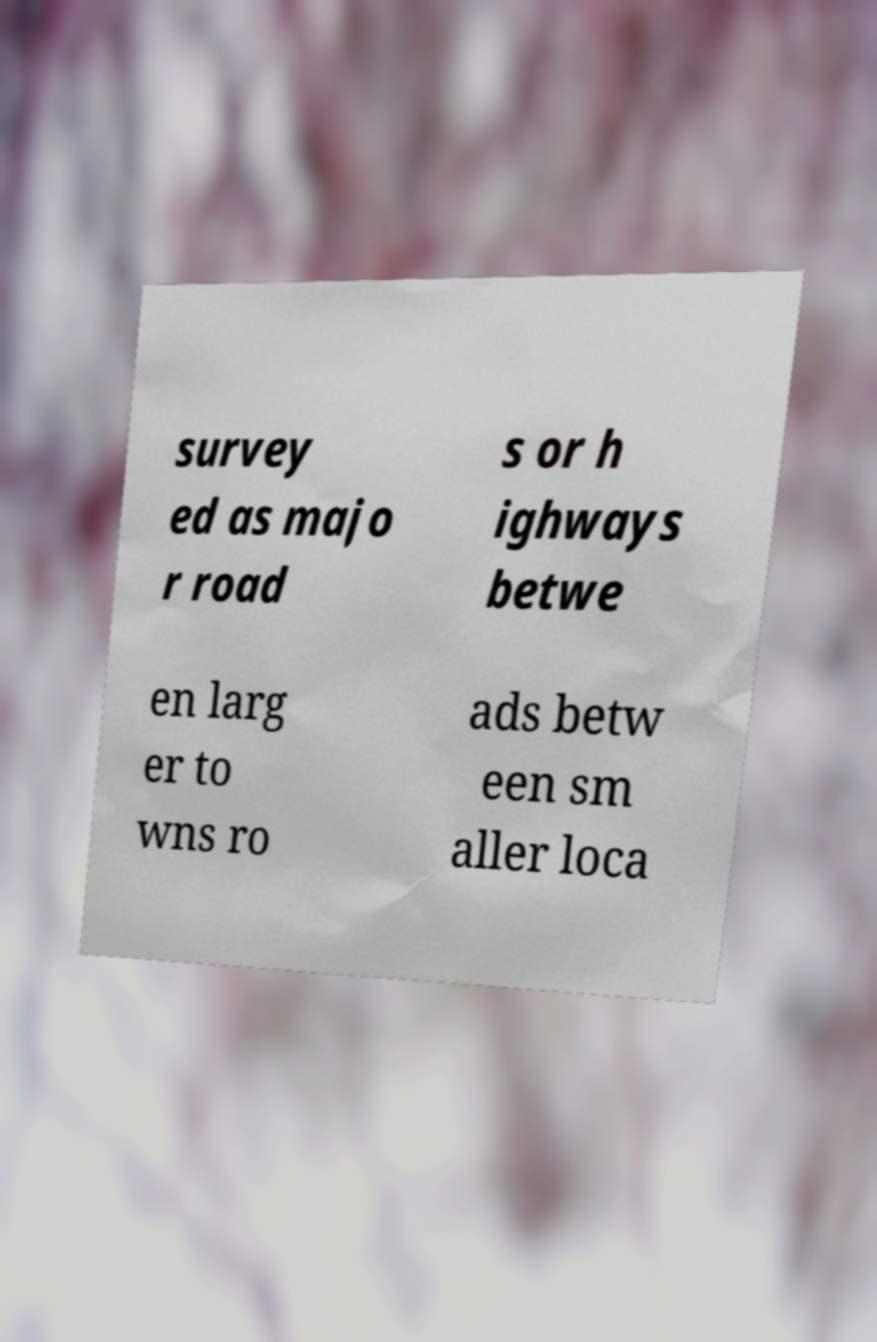Could you assist in decoding the text presented in this image and type it out clearly? survey ed as majo r road s or h ighways betwe en larg er to wns ro ads betw een sm aller loca 